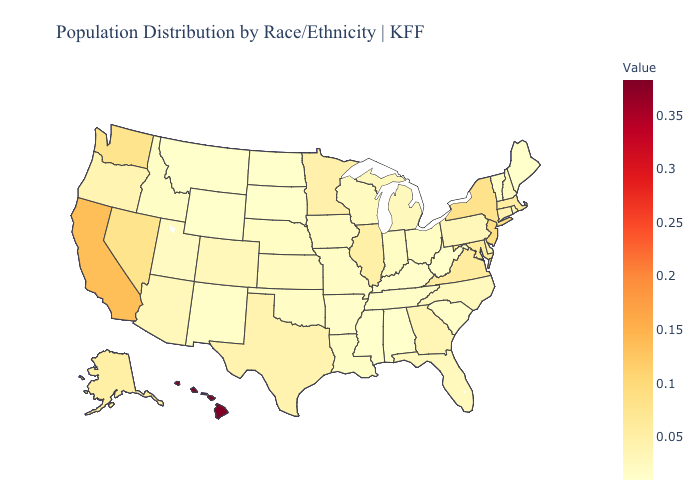Does Maryland have a lower value than Utah?
Concise answer only. No. Is the legend a continuous bar?
Keep it brief. Yes. Is the legend a continuous bar?
Be succinct. Yes. Among the states that border California , which have the highest value?
Answer briefly. Nevada. Which states have the lowest value in the USA?
Keep it brief. Maine, Mississippi, Montana, North Dakota, South Dakota, West Virginia, Wyoming. Which states have the lowest value in the USA?
Concise answer only. Maine, Mississippi, Montana, North Dakota, South Dakota, West Virginia, Wyoming. 